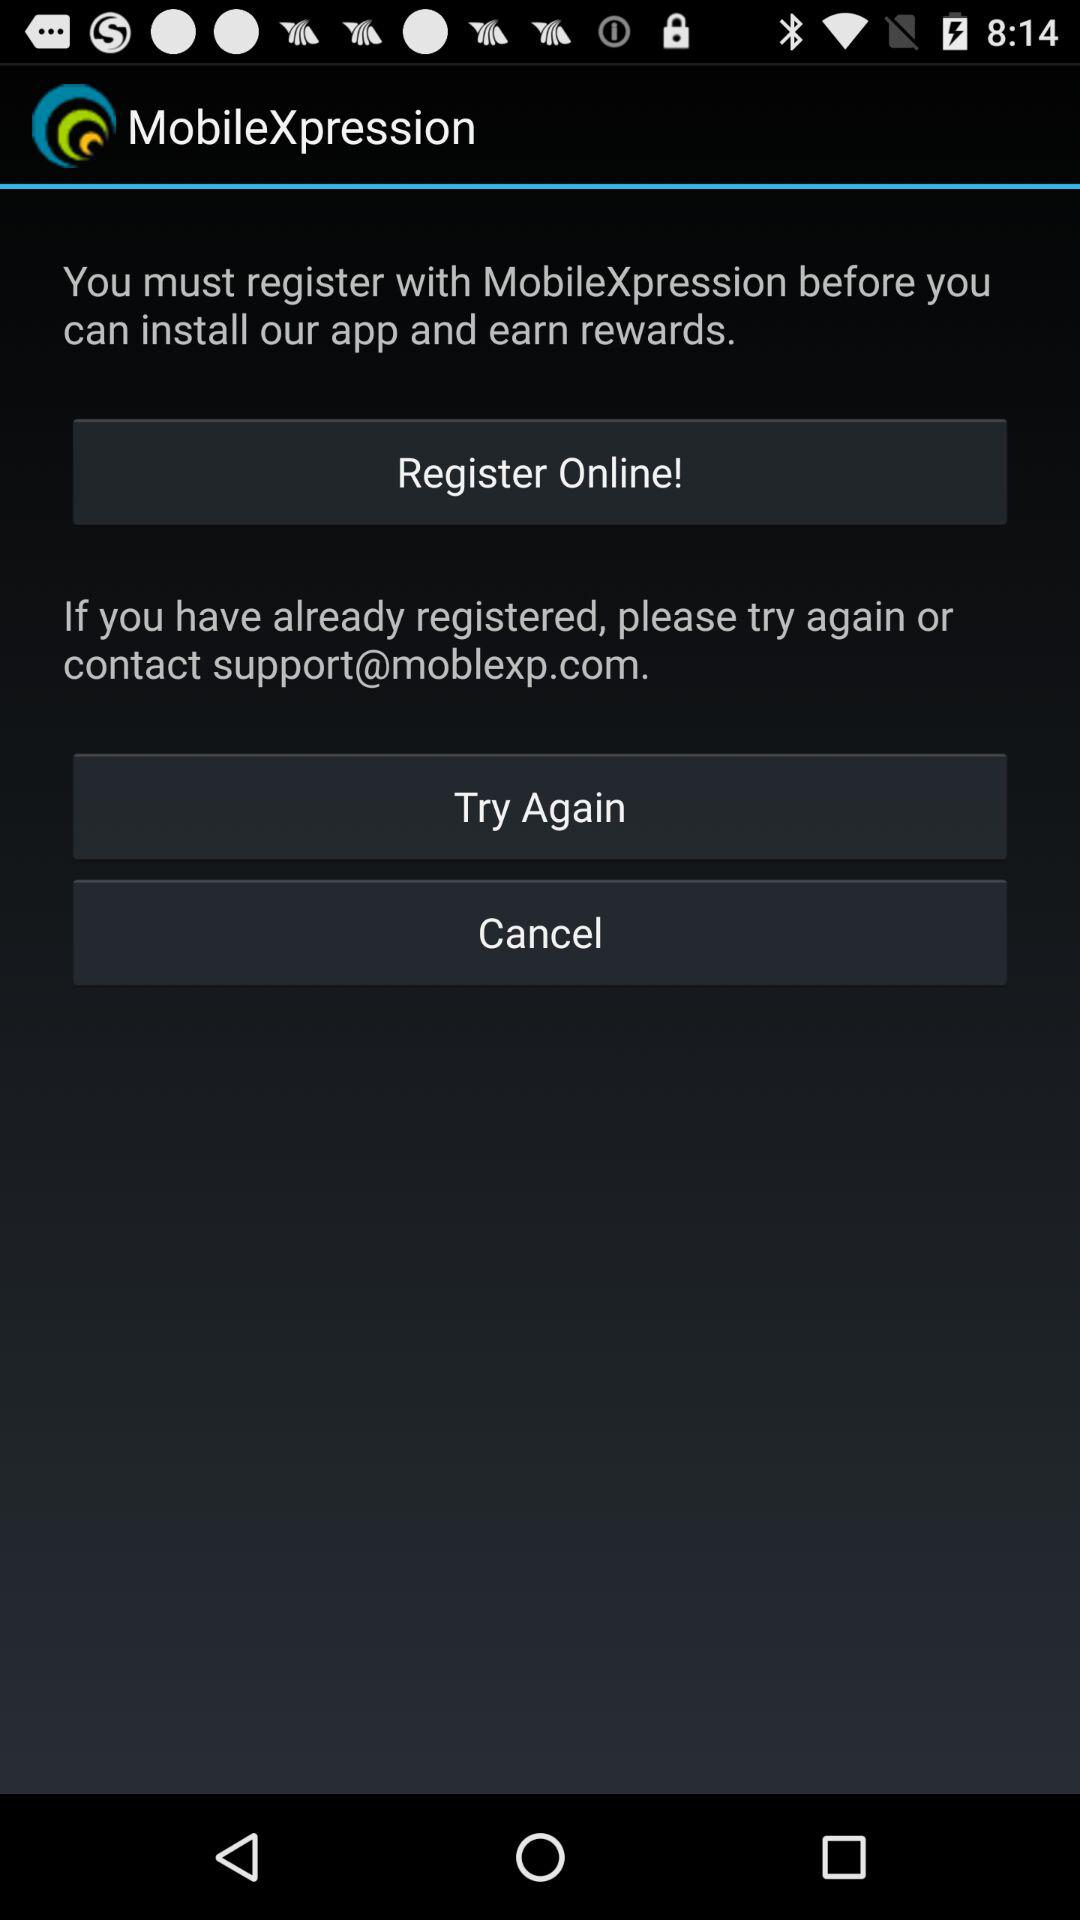What is the email address? The email address is support@moblexp.com. 